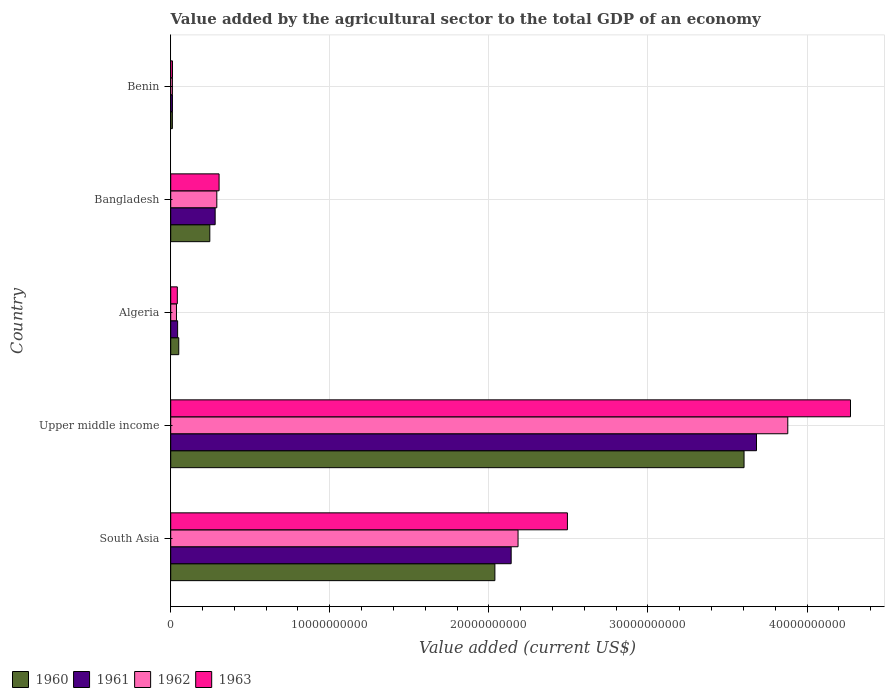How many groups of bars are there?
Give a very brief answer. 5. Are the number of bars per tick equal to the number of legend labels?
Give a very brief answer. Yes. How many bars are there on the 3rd tick from the top?
Offer a very short reply. 4. How many bars are there on the 5th tick from the bottom?
Keep it short and to the point. 4. What is the label of the 4th group of bars from the top?
Offer a terse response. Upper middle income. In how many cases, is the number of bars for a given country not equal to the number of legend labels?
Your answer should be compact. 0. What is the value added by the agricultural sector to the total GDP in 1961 in Benin?
Provide a succinct answer. 1.09e+08. Across all countries, what is the maximum value added by the agricultural sector to the total GDP in 1961?
Your answer should be compact. 3.68e+1. Across all countries, what is the minimum value added by the agricultural sector to the total GDP in 1960?
Ensure brevity in your answer.  1.04e+08. In which country was the value added by the agricultural sector to the total GDP in 1961 maximum?
Offer a very short reply. Upper middle income. In which country was the value added by the agricultural sector to the total GDP in 1963 minimum?
Ensure brevity in your answer.  Benin. What is the total value added by the agricultural sector to the total GDP in 1963 in the graph?
Your response must be concise. 7.12e+1. What is the difference between the value added by the agricultural sector to the total GDP in 1960 in Benin and that in South Asia?
Ensure brevity in your answer.  -2.03e+1. What is the difference between the value added by the agricultural sector to the total GDP in 1963 in Upper middle income and the value added by the agricultural sector to the total GDP in 1961 in Algeria?
Ensure brevity in your answer.  4.23e+1. What is the average value added by the agricultural sector to the total GDP in 1961 per country?
Your answer should be compact. 1.23e+1. What is the difference between the value added by the agricultural sector to the total GDP in 1960 and value added by the agricultural sector to the total GDP in 1962 in South Asia?
Provide a short and direct response. -1.46e+09. What is the ratio of the value added by the agricultural sector to the total GDP in 1960 in Benin to that in Upper middle income?
Keep it short and to the point. 0. What is the difference between the highest and the second highest value added by the agricultural sector to the total GDP in 1962?
Offer a terse response. 1.70e+1. What is the difference between the highest and the lowest value added by the agricultural sector to the total GDP in 1963?
Offer a terse response. 4.26e+1. Is the sum of the value added by the agricultural sector to the total GDP in 1962 in Algeria and Bangladesh greater than the maximum value added by the agricultural sector to the total GDP in 1963 across all countries?
Provide a short and direct response. No. Is it the case that in every country, the sum of the value added by the agricultural sector to the total GDP in 1961 and value added by the agricultural sector to the total GDP in 1960 is greater than the value added by the agricultural sector to the total GDP in 1962?
Offer a very short reply. Yes. How many bars are there?
Offer a very short reply. 20. What is the difference between two consecutive major ticks on the X-axis?
Make the answer very short. 1.00e+1. Does the graph contain any zero values?
Your answer should be very brief. No. Does the graph contain grids?
Make the answer very short. Yes. Where does the legend appear in the graph?
Keep it short and to the point. Bottom left. How many legend labels are there?
Offer a terse response. 4. What is the title of the graph?
Offer a terse response. Value added by the agricultural sector to the total GDP of an economy. What is the label or title of the X-axis?
Provide a succinct answer. Value added (current US$). What is the Value added (current US$) in 1960 in South Asia?
Give a very brief answer. 2.04e+1. What is the Value added (current US$) in 1961 in South Asia?
Your response must be concise. 2.14e+1. What is the Value added (current US$) in 1962 in South Asia?
Offer a terse response. 2.18e+1. What is the Value added (current US$) in 1963 in South Asia?
Your response must be concise. 2.49e+1. What is the Value added (current US$) of 1960 in Upper middle income?
Your response must be concise. 3.60e+1. What is the Value added (current US$) in 1961 in Upper middle income?
Provide a succinct answer. 3.68e+1. What is the Value added (current US$) in 1962 in Upper middle income?
Offer a terse response. 3.88e+1. What is the Value added (current US$) of 1963 in Upper middle income?
Offer a terse response. 4.27e+1. What is the Value added (current US$) in 1960 in Algeria?
Your answer should be very brief. 5.06e+08. What is the Value added (current US$) in 1961 in Algeria?
Provide a short and direct response. 4.34e+08. What is the Value added (current US$) in 1962 in Algeria?
Keep it short and to the point. 3.61e+08. What is the Value added (current US$) in 1963 in Algeria?
Offer a very short reply. 4.16e+08. What is the Value added (current US$) in 1960 in Bangladesh?
Offer a terse response. 2.46e+09. What is the Value added (current US$) in 1961 in Bangladesh?
Provide a short and direct response. 2.79e+09. What is the Value added (current US$) of 1962 in Bangladesh?
Your answer should be very brief. 2.90e+09. What is the Value added (current US$) in 1963 in Bangladesh?
Provide a short and direct response. 3.04e+09. What is the Value added (current US$) in 1960 in Benin?
Make the answer very short. 1.04e+08. What is the Value added (current US$) of 1961 in Benin?
Provide a short and direct response. 1.09e+08. What is the Value added (current US$) in 1962 in Benin?
Your answer should be very brief. 1.06e+08. What is the Value added (current US$) of 1963 in Benin?
Ensure brevity in your answer.  1.11e+08. Across all countries, what is the maximum Value added (current US$) of 1960?
Your answer should be very brief. 3.60e+1. Across all countries, what is the maximum Value added (current US$) of 1961?
Provide a short and direct response. 3.68e+1. Across all countries, what is the maximum Value added (current US$) in 1962?
Give a very brief answer. 3.88e+1. Across all countries, what is the maximum Value added (current US$) in 1963?
Your answer should be very brief. 4.27e+1. Across all countries, what is the minimum Value added (current US$) of 1960?
Your answer should be very brief. 1.04e+08. Across all countries, what is the minimum Value added (current US$) of 1961?
Make the answer very short. 1.09e+08. Across all countries, what is the minimum Value added (current US$) in 1962?
Your answer should be compact. 1.06e+08. Across all countries, what is the minimum Value added (current US$) in 1963?
Give a very brief answer. 1.11e+08. What is the total Value added (current US$) of 1960 in the graph?
Offer a terse response. 5.95e+1. What is the total Value added (current US$) of 1961 in the graph?
Keep it short and to the point. 6.16e+1. What is the total Value added (current US$) of 1962 in the graph?
Ensure brevity in your answer.  6.40e+1. What is the total Value added (current US$) in 1963 in the graph?
Ensure brevity in your answer.  7.12e+1. What is the difference between the Value added (current US$) in 1960 in South Asia and that in Upper middle income?
Offer a terse response. -1.57e+1. What is the difference between the Value added (current US$) of 1961 in South Asia and that in Upper middle income?
Your response must be concise. -1.54e+1. What is the difference between the Value added (current US$) of 1962 in South Asia and that in Upper middle income?
Offer a terse response. -1.70e+1. What is the difference between the Value added (current US$) of 1963 in South Asia and that in Upper middle income?
Provide a short and direct response. -1.78e+1. What is the difference between the Value added (current US$) of 1960 in South Asia and that in Algeria?
Your response must be concise. 1.99e+1. What is the difference between the Value added (current US$) of 1961 in South Asia and that in Algeria?
Your answer should be very brief. 2.10e+1. What is the difference between the Value added (current US$) in 1962 in South Asia and that in Algeria?
Your answer should be compact. 2.15e+1. What is the difference between the Value added (current US$) of 1963 in South Asia and that in Algeria?
Provide a short and direct response. 2.45e+1. What is the difference between the Value added (current US$) of 1960 in South Asia and that in Bangladesh?
Your answer should be very brief. 1.79e+1. What is the difference between the Value added (current US$) of 1961 in South Asia and that in Bangladesh?
Give a very brief answer. 1.86e+1. What is the difference between the Value added (current US$) in 1962 in South Asia and that in Bangladesh?
Offer a very short reply. 1.89e+1. What is the difference between the Value added (current US$) of 1963 in South Asia and that in Bangladesh?
Offer a very short reply. 2.19e+1. What is the difference between the Value added (current US$) of 1960 in South Asia and that in Benin?
Ensure brevity in your answer.  2.03e+1. What is the difference between the Value added (current US$) of 1961 in South Asia and that in Benin?
Ensure brevity in your answer.  2.13e+1. What is the difference between the Value added (current US$) of 1962 in South Asia and that in Benin?
Offer a terse response. 2.17e+1. What is the difference between the Value added (current US$) in 1963 in South Asia and that in Benin?
Ensure brevity in your answer.  2.48e+1. What is the difference between the Value added (current US$) of 1960 in Upper middle income and that in Algeria?
Provide a succinct answer. 3.55e+1. What is the difference between the Value added (current US$) in 1961 in Upper middle income and that in Algeria?
Give a very brief answer. 3.64e+1. What is the difference between the Value added (current US$) of 1962 in Upper middle income and that in Algeria?
Make the answer very short. 3.84e+1. What is the difference between the Value added (current US$) in 1963 in Upper middle income and that in Algeria?
Offer a terse response. 4.23e+1. What is the difference between the Value added (current US$) of 1960 in Upper middle income and that in Bangladesh?
Make the answer very short. 3.36e+1. What is the difference between the Value added (current US$) in 1961 in Upper middle income and that in Bangladesh?
Your response must be concise. 3.40e+1. What is the difference between the Value added (current US$) in 1962 in Upper middle income and that in Bangladesh?
Your answer should be compact. 3.59e+1. What is the difference between the Value added (current US$) in 1963 in Upper middle income and that in Bangladesh?
Keep it short and to the point. 3.97e+1. What is the difference between the Value added (current US$) of 1960 in Upper middle income and that in Benin?
Keep it short and to the point. 3.59e+1. What is the difference between the Value added (current US$) of 1961 in Upper middle income and that in Benin?
Your answer should be very brief. 3.67e+1. What is the difference between the Value added (current US$) of 1962 in Upper middle income and that in Benin?
Provide a succinct answer. 3.87e+1. What is the difference between the Value added (current US$) of 1963 in Upper middle income and that in Benin?
Your answer should be compact. 4.26e+1. What is the difference between the Value added (current US$) in 1960 in Algeria and that in Bangladesh?
Provide a succinct answer. -1.95e+09. What is the difference between the Value added (current US$) of 1961 in Algeria and that in Bangladesh?
Provide a short and direct response. -2.36e+09. What is the difference between the Value added (current US$) in 1962 in Algeria and that in Bangladesh?
Provide a succinct answer. -2.54e+09. What is the difference between the Value added (current US$) in 1963 in Algeria and that in Bangladesh?
Provide a short and direct response. -2.62e+09. What is the difference between the Value added (current US$) of 1960 in Algeria and that in Benin?
Your response must be concise. 4.02e+08. What is the difference between the Value added (current US$) in 1961 in Algeria and that in Benin?
Give a very brief answer. 3.25e+08. What is the difference between the Value added (current US$) in 1962 in Algeria and that in Benin?
Your answer should be compact. 2.56e+08. What is the difference between the Value added (current US$) of 1963 in Algeria and that in Benin?
Your response must be concise. 3.05e+08. What is the difference between the Value added (current US$) in 1960 in Bangladesh and that in Benin?
Offer a terse response. 2.35e+09. What is the difference between the Value added (current US$) in 1961 in Bangladesh and that in Benin?
Offer a very short reply. 2.68e+09. What is the difference between the Value added (current US$) of 1962 in Bangladesh and that in Benin?
Provide a short and direct response. 2.79e+09. What is the difference between the Value added (current US$) in 1963 in Bangladesh and that in Benin?
Provide a succinct answer. 2.93e+09. What is the difference between the Value added (current US$) in 1960 in South Asia and the Value added (current US$) in 1961 in Upper middle income?
Ensure brevity in your answer.  -1.64e+1. What is the difference between the Value added (current US$) in 1960 in South Asia and the Value added (current US$) in 1962 in Upper middle income?
Provide a short and direct response. -1.84e+1. What is the difference between the Value added (current US$) in 1960 in South Asia and the Value added (current US$) in 1963 in Upper middle income?
Make the answer very short. -2.24e+1. What is the difference between the Value added (current US$) in 1961 in South Asia and the Value added (current US$) in 1962 in Upper middle income?
Give a very brief answer. -1.74e+1. What is the difference between the Value added (current US$) of 1961 in South Asia and the Value added (current US$) of 1963 in Upper middle income?
Offer a very short reply. -2.13e+1. What is the difference between the Value added (current US$) in 1962 in South Asia and the Value added (current US$) in 1963 in Upper middle income?
Keep it short and to the point. -2.09e+1. What is the difference between the Value added (current US$) of 1960 in South Asia and the Value added (current US$) of 1961 in Algeria?
Offer a terse response. 1.99e+1. What is the difference between the Value added (current US$) in 1960 in South Asia and the Value added (current US$) in 1962 in Algeria?
Keep it short and to the point. 2.00e+1. What is the difference between the Value added (current US$) in 1960 in South Asia and the Value added (current US$) in 1963 in Algeria?
Give a very brief answer. 2.00e+1. What is the difference between the Value added (current US$) in 1961 in South Asia and the Value added (current US$) in 1962 in Algeria?
Offer a terse response. 2.10e+1. What is the difference between the Value added (current US$) of 1961 in South Asia and the Value added (current US$) of 1963 in Algeria?
Provide a short and direct response. 2.10e+1. What is the difference between the Value added (current US$) in 1962 in South Asia and the Value added (current US$) in 1963 in Algeria?
Your answer should be very brief. 2.14e+1. What is the difference between the Value added (current US$) of 1960 in South Asia and the Value added (current US$) of 1961 in Bangladesh?
Provide a short and direct response. 1.76e+1. What is the difference between the Value added (current US$) in 1960 in South Asia and the Value added (current US$) in 1962 in Bangladesh?
Provide a short and direct response. 1.75e+1. What is the difference between the Value added (current US$) in 1960 in South Asia and the Value added (current US$) in 1963 in Bangladesh?
Offer a terse response. 1.73e+1. What is the difference between the Value added (current US$) of 1961 in South Asia and the Value added (current US$) of 1962 in Bangladesh?
Give a very brief answer. 1.85e+1. What is the difference between the Value added (current US$) in 1961 in South Asia and the Value added (current US$) in 1963 in Bangladesh?
Your answer should be compact. 1.84e+1. What is the difference between the Value added (current US$) of 1962 in South Asia and the Value added (current US$) of 1963 in Bangladesh?
Your answer should be very brief. 1.88e+1. What is the difference between the Value added (current US$) of 1960 in South Asia and the Value added (current US$) of 1961 in Benin?
Provide a short and direct response. 2.03e+1. What is the difference between the Value added (current US$) of 1960 in South Asia and the Value added (current US$) of 1962 in Benin?
Ensure brevity in your answer.  2.03e+1. What is the difference between the Value added (current US$) of 1960 in South Asia and the Value added (current US$) of 1963 in Benin?
Your answer should be compact. 2.03e+1. What is the difference between the Value added (current US$) of 1961 in South Asia and the Value added (current US$) of 1962 in Benin?
Ensure brevity in your answer.  2.13e+1. What is the difference between the Value added (current US$) of 1961 in South Asia and the Value added (current US$) of 1963 in Benin?
Provide a succinct answer. 2.13e+1. What is the difference between the Value added (current US$) in 1962 in South Asia and the Value added (current US$) in 1963 in Benin?
Your response must be concise. 2.17e+1. What is the difference between the Value added (current US$) of 1960 in Upper middle income and the Value added (current US$) of 1961 in Algeria?
Your answer should be compact. 3.56e+1. What is the difference between the Value added (current US$) in 1960 in Upper middle income and the Value added (current US$) in 1962 in Algeria?
Keep it short and to the point. 3.57e+1. What is the difference between the Value added (current US$) of 1960 in Upper middle income and the Value added (current US$) of 1963 in Algeria?
Provide a short and direct response. 3.56e+1. What is the difference between the Value added (current US$) of 1961 in Upper middle income and the Value added (current US$) of 1962 in Algeria?
Offer a very short reply. 3.65e+1. What is the difference between the Value added (current US$) in 1961 in Upper middle income and the Value added (current US$) in 1963 in Algeria?
Provide a short and direct response. 3.64e+1. What is the difference between the Value added (current US$) in 1962 in Upper middle income and the Value added (current US$) in 1963 in Algeria?
Give a very brief answer. 3.84e+1. What is the difference between the Value added (current US$) in 1960 in Upper middle income and the Value added (current US$) in 1961 in Bangladesh?
Offer a very short reply. 3.32e+1. What is the difference between the Value added (current US$) of 1960 in Upper middle income and the Value added (current US$) of 1962 in Bangladesh?
Make the answer very short. 3.31e+1. What is the difference between the Value added (current US$) in 1960 in Upper middle income and the Value added (current US$) in 1963 in Bangladesh?
Give a very brief answer. 3.30e+1. What is the difference between the Value added (current US$) in 1961 in Upper middle income and the Value added (current US$) in 1962 in Bangladesh?
Give a very brief answer. 3.39e+1. What is the difference between the Value added (current US$) of 1961 in Upper middle income and the Value added (current US$) of 1963 in Bangladesh?
Keep it short and to the point. 3.38e+1. What is the difference between the Value added (current US$) of 1962 in Upper middle income and the Value added (current US$) of 1963 in Bangladesh?
Provide a short and direct response. 3.57e+1. What is the difference between the Value added (current US$) of 1960 in Upper middle income and the Value added (current US$) of 1961 in Benin?
Provide a short and direct response. 3.59e+1. What is the difference between the Value added (current US$) in 1960 in Upper middle income and the Value added (current US$) in 1962 in Benin?
Keep it short and to the point. 3.59e+1. What is the difference between the Value added (current US$) in 1960 in Upper middle income and the Value added (current US$) in 1963 in Benin?
Make the answer very short. 3.59e+1. What is the difference between the Value added (current US$) in 1961 in Upper middle income and the Value added (current US$) in 1962 in Benin?
Your answer should be very brief. 3.67e+1. What is the difference between the Value added (current US$) of 1961 in Upper middle income and the Value added (current US$) of 1963 in Benin?
Your answer should be very brief. 3.67e+1. What is the difference between the Value added (current US$) in 1962 in Upper middle income and the Value added (current US$) in 1963 in Benin?
Your answer should be very brief. 3.87e+1. What is the difference between the Value added (current US$) of 1960 in Algeria and the Value added (current US$) of 1961 in Bangladesh?
Keep it short and to the point. -2.29e+09. What is the difference between the Value added (current US$) of 1960 in Algeria and the Value added (current US$) of 1962 in Bangladesh?
Your response must be concise. -2.39e+09. What is the difference between the Value added (current US$) in 1960 in Algeria and the Value added (current US$) in 1963 in Bangladesh?
Your answer should be compact. -2.53e+09. What is the difference between the Value added (current US$) of 1961 in Algeria and the Value added (current US$) of 1962 in Bangladesh?
Ensure brevity in your answer.  -2.46e+09. What is the difference between the Value added (current US$) of 1961 in Algeria and the Value added (current US$) of 1963 in Bangladesh?
Provide a succinct answer. -2.61e+09. What is the difference between the Value added (current US$) in 1962 in Algeria and the Value added (current US$) in 1963 in Bangladesh?
Your answer should be compact. -2.68e+09. What is the difference between the Value added (current US$) of 1960 in Algeria and the Value added (current US$) of 1961 in Benin?
Give a very brief answer. 3.97e+08. What is the difference between the Value added (current US$) of 1960 in Algeria and the Value added (current US$) of 1962 in Benin?
Provide a short and direct response. 4.00e+08. What is the difference between the Value added (current US$) in 1960 in Algeria and the Value added (current US$) in 1963 in Benin?
Give a very brief answer. 3.95e+08. What is the difference between the Value added (current US$) in 1961 in Algeria and the Value added (current US$) in 1962 in Benin?
Your answer should be very brief. 3.28e+08. What is the difference between the Value added (current US$) of 1961 in Algeria and the Value added (current US$) of 1963 in Benin?
Make the answer very short. 3.23e+08. What is the difference between the Value added (current US$) in 1962 in Algeria and the Value added (current US$) in 1963 in Benin?
Make the answer very short. 2.50e+08. What is the difference between the Value added (current US$) in 1960 in Bangladesh and the Value added (current US$) in 1961 in Benin?
Keep it short and to the point. 2.35e+09. What is the difference between the Value added (current US$) in 1960 in Bangladesh and the Value added (current US$) in 1962 in Benin?
Keep it short and to the point. 2.35e+09. What is the difference between the Value added (current US$) of 1960 in Bangladesh and the Value added (current US$) of 1963 in Benin?
Provide a succinct answer. 2.35e+09. What is the difference between the Value added (current US$) in 1961 in Bangladesh and the Value added (current US$) in 1962 in Benin?
Give a very brief answer. 2.69e+09. What is the difference between the Value added (current US$) of 1961 in Bangladesh and the Value added (current US$) of 1963 in Benin?
Give a very brief answer. 2.68e+09. What is the difference between the Value added (current US$) of 1962 in Bangladesh and the Value added (current US$) of 1963 in Benin?
Ensure brevity in your answer.  2.79e+09. What is the average Value added (current US$) in 1960 per country?
Your answer should be compact. 1.19e+1. What is the average Value added (current US$) in 1961 per country?
Keep it short and to the point. 1.23e+1. What is the average Value added (current US$) of 1962 per country?
Provide a succinct answer. 1.28e+1. What is the average Value added (current US$) in 1963 per country?
Offer a very short reply. 1.42e+1. What is the difference between the Value added (current US$) in 1960 and Value added (current US$) in 1961 in South Asia?
Make the answer very short. -1.02e+09. What is the difference between the Value added (current US$) in 1960 and Value added (current US$) in 1962 in South Asia?
Your answer should be compact. -1.46e+09. What is the difference between the Value added (current US$) in 1960 and Value added (current US$) in 1963 in South Asia?
Provide a short and direct response. -4.56e+09. What is the difference between the Value added (current US$) of 1961 and Value added (current US$) of 1962 in South Asia?
Ensure brevity in your answer.  -4.32e+08. What is the difference between the Value added (current US$) in 1961 and Value added (current US$) in 1963 in South Asia?
Provide a short and direct response. -3.54e+09. What is the difference between the Value added (current US$) in 1962 and Value added (current US$) in 1963 in South Asia?
Offer a terse response. -3.10e+09. What is the difference between the Value added (current US$) in 1960 and Value added (current US$) in 1961 in Upper middle income?
Your response must be concise. -7.82e+08. What is the difference between the Value added (current US$) in 1960 and Value added (current US$) in 1962 in Upper middle income?
Your answer should be very brief. -2.75e+09. What is the difference between the Value added (current US$) of 1960 and Value added (current US$) of 1963 in Upper middle income?
Your response must be concise. -6.69e+09. What is the difference between the Value added (current US$) of 1961 and Value added (current US$) of 1962 in Upper middle income?
Your response must be concise. -1.97e+09. What is the difference between the Value added (current US$) in 1961 and Value added (current US$) in 1963 in Upper middle income?
Offer a very short reply. -5.91e+09. What is the difference between the Value added (current US$) in 1962 and Value added (current US$) in 1963 in Upper middle income?
Provide a succinct answer. -3.94e+09. What is the difference between the Value added (current US$) in 1960 and Value added (current US$) in 1961 in Algeria?
Your answer should be very brief. 7.23e+07. What is the difference between the Value added (current US$) of 1960 and Value added (current US$) of 1962 in Algeria?
Your answer should be very brief. 1.45e+08. What is the difference between the Value added (current US$) of 1960 and Value added (current US$) of 1963 in Algeria?
Give a very brief answer. 9.04e+07. What is the difference between the Value added (current US$) in 1961 and Value added (current US$) in 1962 in Algeria?
Your answer should be compact. 7.23e+07. What is the difference between the Value added (current US$) of 1961 and Value added (current US$) of 1963 in Algeria?
Your response must be concise. 1.81e+07. What is the difference between the Value added (current US$) of 1962 and Value added (current US$) of 1963 in Algeria?
Ensure brevity in your answer.  -5.42e+07. What is the difference between the Value added (current US$) in 1960 and Value added (current US$) in 1961 in Bangladesh?
Provide a short and direct response. -3.37e+08. What is the difference between the Value added (current US$) in 1960 and Value added (current US$) in 1962 in Bangladesh?
Offer a terse response. -4.40e+08. What is the difference between the Value added (current US$) of 1960 and Value added (current US$) of 1963 in Bangladesh?
Make the answer very short. -5.83e+08. What is the difference between the Value added (current US$) in 1961 and Value added (current US$) in 1962 in Bangladesh?
Provide a short and direct response. -1.04e+08. What is the difference between the Value added (current US$) of 1961 and Value added (current US$) of 1963 in Bangladesh?
Ensure brevity in your answer.  -2.46e+08. What is the difference between the Value added (current US$) in 1962 and Value added (current US$) in 1963 in Bangladesh?
Offer a very short reply. -1.43e+08. What is the difference between the Value added (current US$) in 1960 and Value added (current US$) in 1961 in Benin?
Offer a terse response. -4.46e+06. What is the difference between the Value added (current US$) of 1960 and Value added (current US$) of 1962 in Benin?
Provide a short and direct response. -1.30e+06. What is the difference between the Value added (current US$) of 1960 and Value added (current US$) of 1963 in Benin?
Your answer should be compact. -6.61e+06. What is the difference between the Value added (current US$) in 1961 and Value added (current US$) in 1962 in Benin?
Offer a very short reply. 3.16e+06. What is the difference between the Value added (current US$) of 1961 and Value added (current US$) of 1963 in Benin?
Your answer should be very brief. -2.15e+06. What is the difference between the Value added (current US$) in 1962 and Value added (current US$) in 1963 in Benin?
Provide a succinct answer. -5.30e+06. What is the ratio of the Value added (current US$) of 1960 in South Asia to that in Upper middle income?
Offer a very short reply. 0.57. What is the ratio of the Value added (current US$) in 1961 in South Asia to that in Upper middle income?
Make the answer very short. 0.58. What is the ratio of the Value added (current US$) of 1962 in South Asia to that in Upper middle income?
Make the answer very short. 0.56. What is the ratio of the Value added (current US$) of 1963 in South Asia to that in Upper middle income?
Make the answer very short. 0.58. What is the ratio of the Value added (current US$) in 1960 in South Asia to that in Algeria?
Keep it short and to the point. 40.26. What is the ratio of the Value added (current US$) of 1961 in South Asia to that in Algeria?
Give a very brief answer. 49.33. What is the ratio of the Value added (current US$) in 1962 in South Asia to that in Algeria?
Your response must be concise. 60.39. What is the ratio of the Value added (current US$) in 1963 in South Asia to that in Algeria?
Ensure brevity in your answer.  59.98. What is the ratio of the Value added (current US$) in 1960 in South Asia to that in Bangladesh?
Make the answer very short. 8.29. What is the ratio of the Value added (current US$) in 1961 in South Asia to that in Bangladesh?
Offer a very short reply. 7.66. What is the ratio of the Value added (current US$) in 1962 in South Asia to that in Bangladesh?
Give a very brief answer. 7.54. What is the ratio of the Value added (current US$) in 1963 in South Asia to that in Bangladesh?
Offer a very short reply. 8.2. What is the ratio of the Value added (current US$) in 1960 in South Asia to that in Benin?
Ensure brevity in your answer.  195.16. What is the ratio of the Value added (current US$) of 1961 in South Asia to that in Benin?
Your answer should be compact. 196.57. What is the ratio of the Value added (current US$) of 1962 in South Asia to that in Benin?
Give a very brief answer. 206.53. What is the ratio of the Value added (current US$) in 1963 in South Asia to that in Benin?
Your answer should be compact. 224.62. What is the ratio of the Value added (current US$) in 1960 in Upper middle income to that in Algeria?
Make the answer very short. 71.21. What is the ratio of the Value added (current US$) of 1961 in Upper middle income to that in Algeria?
Ensure brevity in your answer.  84.88. What is the ratio of the Value added (current US$) in 1962 in Upper middle income to that in Algeria?
Make the answer very short. 107.3. What is the ratio of the Value added (current US$) in 1963 in Upper middle income to that in Algeria?
Your response must be concise. 102.79. What is the ratio of the Value added (current US$) of 1960 in Upper middle income to that in Bangladesh?
Your answer should be compact. 14.67. What is the ratio of the Value added (current US$) of 1961 in Upper middle income to that in Bangladesh?
Provide a succinct answer. 13.18. What is the ratio of the Value added (current US$) in 1962 in Upper middle income to that in Bangladesh?
Provide a succinct answer. 13.39. What is the ratio of the Value added (current US$) of 1963 in Upper middle income to that in Bangladesh?
Provide a short and direct response. 14.06. What is the ratio of the Value added (current US$) in 1960 in Upper middle income to that in Benin?
Make the answer very short. 345.17. What is the ratio of the Value added (current US$) in 1961 in Upper middle income to that in Benin?
Ensure brevity in your answer.  338.22. What is the ratio of the Value added (current US$) of 1962 in Upper middle income to that in Benin?
Your answer should be very brief. 366.93. What is the ratio of the Value added (current US$) of 1963 in Upper middle income to that in Benin?
Make the answer very short. 384.91. What is the ratio of the Value added (current US$) in 1960 in Algeria to that in Bangladesh?
Provide a short and direct response. 0.21. What is the ratio of the Value added (current US$) of 1961 in Algeria to that in Bangladesh?
Ensure brevity in your answer.  0.16. What is the ratio of the Value added (current US$) in 1962 in Algeria to that in Bangladesh?
Your answer should be very brief. 0.12. What is the ratio of the Value added (current US$) of 1963 in Algeria to that in Bangladesh?
Offer a terse response. 0.14. What is the ratio of the Value added (current US$) in 1960 in Algeria to that in Benin?
Your response must be concise. 4.85. What is the ratio of the Value added (current US$) of 1961 in Algeria to that in Benin?
Give a very brief answer. 3.98. What is the ratio of the Value added (current US$) of 1962 in Algeria to that in Benin?
Ensure brevity in your answer.  3.42. What is the ratio of the Value added (current US$) in 1963 in Algeria to that in Benin?
Provide a succinct answer. 3.74. What is the ratio of the Value added (current US$) in 1960 in Bangladesh to that in Benin?
Offer a terse response. 23.53. What is the ratio of the Value added (current US$) of 1961 in Bangladesh to that in Benin?
Keep it short and to the point. 25.66. What is the ratio of the Value added (current US$) of 1962 in Bangladesh to that in Benin?
Provide a short and direct response. 27.41. What is the ratio of the Value added (current US$) of 1963 in Bangladesh to that in Benin?
Offer a terse response. 27.38. What is the difference between the highest and the second highest Value added (current US$) of 1960?
Offer a terse response. 1.57e+1. What is the difference between the highest and the second highest Value added (current US$) in 1961?
Your answer should be very brief. 1.54e+1. What is the difference between the highest and the second highest Value added (current US$) of 1962?
Your response must be concise. 1.70e+1. What is the difference between the highest and the second highest Value added (current US$) of 1963?
Provide a short and direct response. 1.78e+1. What is the difference between the highest and the lowest Value added (current US$) in 1960?
Make the answer very short. 3.59e+1. What is the difference between the highest and the lowest Value added (current US$) in 1961?
Keep it short and to the point. 3.67e+1. What is the difference between the highest and the lowest Value added (current US$) of 1962?
Provide a succinct answer. 3.87e+1. What is the difference between the highest and the lowest Value added (current US$) in 1963?
Your response must be concise. 4.26e+1. 